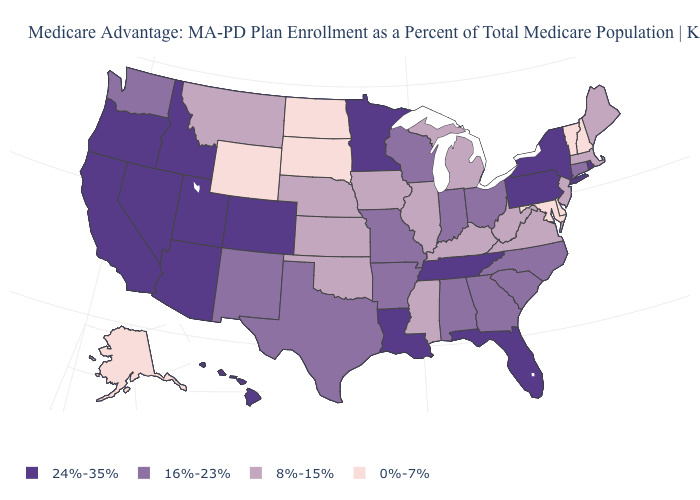Which states have the lowest value in the USA?
Be succinct. Alaska, Delaware, Maryland, North Dakota, New Hampshire, South Dakota, Vermont, Wyoming. What is the value of Pennsylvania?
Give a very brief answer. 24%-35%. Among the states that border Arizona , does New Mexico have the lowest value?
Keep it brief. Yes. What is the highest value in the USA?
Write a very short answer. 24%-35%. Which states have the lowest value in the USA?
Concise answer only. Alaska, Delaware, Maryland, North Dakota, New Hampshire, South Dakota, Vermont, Wyoming. Among the states that border New Hampshire , does Maine have the highest value?
Concise answer only. Yes. What is the lowest value in the South?
Short answer required. 0%-7%. What is the lowest value in states that border Montana?
Quick response, please. 0%-7%. Name the states that have a value in the range 0%-7%?
Quick response, please. Alaska, Delaware, Maryland, North Dakota, New Hampshire, South Dakota, Vermont, Wyoming. What is the value of Virginia?
Answer briefly. 8%-15%. Among the states that border Tennessee , which have the lowest value?
Answer briefly. Kentucky, Mississippi, Virginia. Which states hav the highest value in the South?
Concise answer only. Florida, Louisiana, Tennessee. What is the value of Pennsylvania?
Short answer required. 24%-35%. Name the states that have a value in the range 16%-23%?
Give a very brief answer. Alabama, Arkansas, Connecticut, Georgia, Indiana, Missouri, North Carolina, New Mexico, Ohio, South Carolina, Texas, Washington, Wisconsin. 